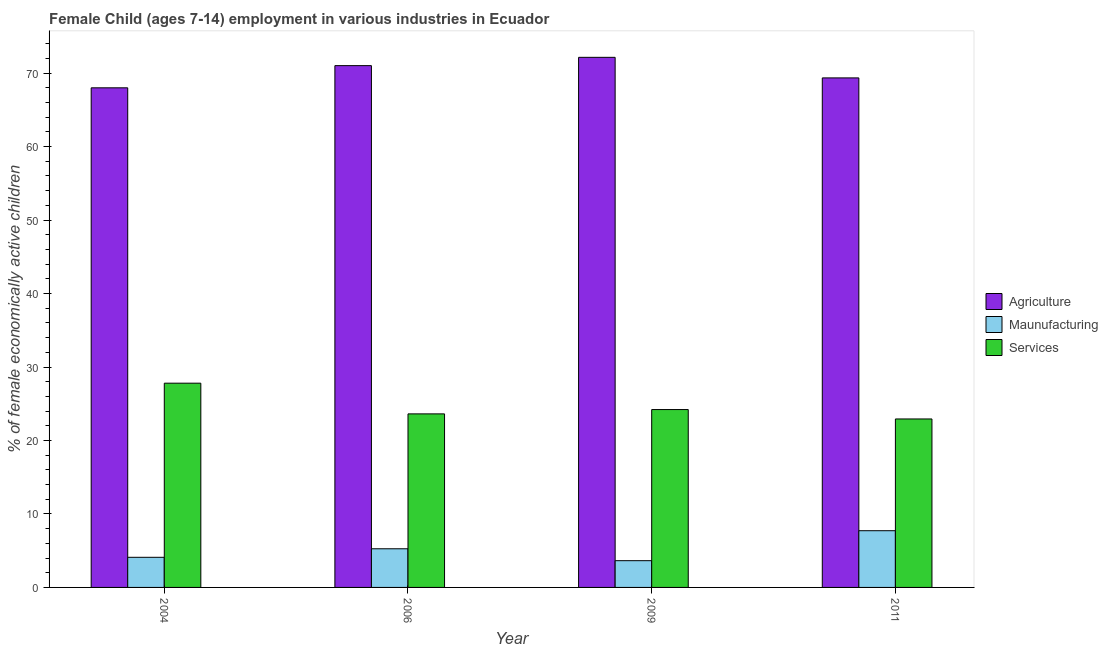How many different coloured bars are there?
Give a very brief answer. 3. How many groups of bars are there?
Provide a short and direct response. 4. Are the number of bars per tick equal to the number of legend labels?
Keep it short and to the point. Yes. How many bars are there on the 2nd tick from the left?
Offer a very short reply. 3. How many bars are there on the 2nd tick from the right?
Your answer should be very brief. 3. What is the label of the 1st group of bars from the left?
Provide a succinct answer. 2004. In how many cases, is the number of bars for a given year not equal to the number of legend labels?
Provide a short and direct response. 0. What is the percentage of economically active children in services in 2009?
Make the answer very short. 24.21. Across all years, what is the maximum percentage of economically active children in services?
Keep it short and to the point. 27.8. Across all years, what is the minimum percentage of economically active children in agriculture?
Make the answer very short. 68. In which year was the percentage of economically active children in services maximum?
Your answer should be compact. 2004. In which year was the percentage of economically active children in manufacturing minimum?
Ensure brevity in your answer.  2009. What is the total percentage of economically active children in agriculture in the graph?
Your answer should be compact. 280.52. What is the difference between the percentage of economically active children in services in 2009 and that in 2011?
Ensure brevity in your answer.  1.28. What is the difference between the percentage of economically active children in services in 2011 and the percentage of economically active children in agriculture in 2009?
Ensure brevity in your answer.  -1.28. What is the average percentage of economically active children in manufacturing per year?
Offer a terse response. 5.18. In how many years, is the percentage of economically active children in services greater than 30 %?
Give a very brief answer. 0. What is the ratio of the percentage of economically active children in agriculture in 2004 to that in 2009?
Give a very brief answer. 0.94. Is the percentage of economically active children in agriculture in 2004 less than that in 2011?
Your answer should be very brief. Yes. What is the difference between the highest and the second highest percentage of economically active children in agriculture?
Provide a short and direct response. 1.13. What is the difference between the highest and the lowest percentage of economically active children in manufacturing?
Ensure brevity in your answer.  4.08. Is the sum of the percentage of economically active children in agriculture in 2004 and 2006 greater than the maximum percentage of economically active children in manufacturing across all years?
Your answer should be very brief. Yes. What does the 2nd bar from the left in 2011 represents?
Keep it short and to the point. Maunufacturing. What does the 1st bar from the right in 2006 represents?
Offer a very short reply. Services. Is it the case that in every year, the sum of the percentage of economically active children in agriculture and percentage of economically active children in manufacturing is greater than the percentage of economically active children in services?
Keep it short and to the point. Yes. Are all the bars in the graph horizontal?
Provide a succinct answer. No. Are the values on the major ticks of Y-axis written in scientific E-notation?
Keep it short and to the point. No. Does the graph contain any zero values?
Give a very brief answer. No. Where does the legend appear in the graph?
Ensure brevity in your answer.  Center right. How many legend labels are there?
Make the answer very short. 3. What is the title of the graph?
Provide a short and direct response. Female Child (ages 7-14) employment in various industries in Ecuador. Does "ICT services" appear as one of the legend labels in the graph?
Your response must be concise. No. What is the label or title of the X-axis?
Offer a very short reply. Year. What is the label or title of the Y-axis?
Keep it short and to the point. % of female economically active children. What is the % of female economically active children in Maunufacturing in 2004?
Your answer should be compact. 4.1. What is the % of female economically active children in Services in 2004?
Give a very brief answer. 27.8. What is the % of female economically active children in Agriculture in 2006?
Provide a short and direct response. 71.02. What is the % of female economically active children of Maunufacturing in 2006?
Make the answer very short. 5.26. What is the % of female economically active children in Services in 2006?
Offer a terse response. 23.62. What is the % of female economically active children in Agriculture in 2009?
Ensure brevity in your answer.  72.15. What is the % of female economically active children in Maunufacturing in 2009?
Offer a very short reply. 3.64. What is the % of female economically active children of Services in 2009?
Keep it short and to the point. 24.21. What is the % of female economically active children in Agriculture in 2011?
Provide a succinct answer. 69.35. What is the % of female economically active children in Maunufacturing in 2011?
Give a very brief answer. 7.72. What is the % of female economically active children in Services in 2011?
Your response must be concise. 22.93. Across all years, what is the maximum % of female economically active children of Agriculture?
Ensure brevity in your answer.  72.15. Across all years, what is the maximum % of female economically active children of Maunufacturing?
Provide a succinct answer. 7.72. Across all years, what is the maximum % of female economically active children of Services?
Your answer should be very brief. 27.8. Across all years, what is the minimum % of female economically active children of Agriculture?
Offer a very short reply. 68. Across all years, what is the minimum % of female economically active children of Maunufacturing?
Ensure brevity in your answer.  3.64. Across all years, what is the minimum % of female economically active children in Services?
Give a very brief answer. 22.93. What is the total % of female economically active children in Agriculture in the graph?
Make the answer very short. 280.52. What is the total % of female economically active children of Maunufacturing in the graph?
Keep it short and to the point. 20.72. What is the total % of female economically active children of Services in the graph?
Offer a very short reply. 98.56. What is the difference between the % of female economically active children of Agriculture in 2004 and that in 2006?
Offer a terse response. -3.02. What is the difference between the % of female economically active children of Maunufacturing in 2004 and that in 2006?
Make the answer very short. -1.16. What is the difference between the % of female economically active children in Services in 2004 and that in 2006?
Provide a short and direct response. 4.18. What is the difference between the % of female economically active children in Agriculture in 2004 and that in 2009?
Offer a very short reply. -4.15. What is the difference between the % of female economically active children of Maunufacturing in 2004 and that in 2009?
Ensure brevity in your answer.  0.46. What is the difference between the % of female economically active children of Services in 2004 and that in 2009?
Ensure brevity in your answer.  3.59. What is the difference between the % of female economically active children in Agriculture in 2004 and that in 2011?
Provide a succinct answer. -1.35. What is the difference between the % of female economically active children of Maunufacturing in 2004 and that in 2011?
Your response must be concise. -3.62. What is the difference between the % of female economically active children of Services in 2004 and that in 2011?
Your answer should be very brief. 4.87. What is the difference between the % of female economically active children of Agriculture in 2006 and that in 2009?
Provide a succinct answer. -1.13. What is the difference between the % of female economically active children of Maunufacturing in 2006 and that in 2009?
Your answer should be very brief. 1.62. What is the difference between the % of female economically active children of Services in 2006 and that in 2009?
Provide a succinct answer. -0.59. What is the difference between the % of female economically active children in Agriculture in 2006 and that in 2011?
Ensure brevity in your answer.  1.67. What is the difference between the % of female economically active children of Maunufacturing in 2006 and that in 2011?
Your answer should be very brief. -2.46. What is the difference between the % of female economically active children of Services in 2006 and that in 2011?
Offer a very short reply. 0.69. What is the difference between the % of female economically active children in Agriculture in 2009 and that in 2011?
Provide a succinct answer. 2.8. What is the difference between the % of female economically active children in Maunufacturing in 2009 and that in 2011?
Ensure brevity in your answer.  -4.08. What is the difference between the % of female economically active children in Services in 2009 and that in 2011?
Offer a terse response. 1.28. What is the difference between the % of female economically active children of Agriculture in 2004 and the % of female economically active children of Maunufacturing in 2006?
Your response must be concise. 62.74. What is the difference between the % of female economically active children of Agriculture in 2004 and the % of female economically active children of Services in 2006?
Provide a succinct answer. 44.38. What is the difference between the % of female economically active children of Maunufacturing in 2004 and the % of female economically active children of Services in 2006?
Give a very brief answer. -19.52. What is the difference between the % of female economically active children in Agriculture in 2004 and the % of female economically active children in Maunufacturing in 2009?
Ensure brevity in your answer.  64.36. What is the difference between the % of female economically active children of Agriculture in 2004 and the % of female economically active children of Services in 2009?
Make the answer very short. 43.79. What is the difference between the % of female economically active children in Maunufacturing in 2004 and the % of female economically active children in Services in 2009?
Your answer should be compact. -20.11. What is the difference between the % of female economically active children of Agriculture in 2004 and the % of female economically active children of Maunufacturing in 2011?
Give a very brief answer. 60.28. What is the difference between the % of female economically active children in Agriculture in 2004 and the % of female economically active children in Services in 2011?
Your answer should be compact. 45.07. What is the difference between the % of female economically active children of Maunufacturing in 2004 and the % of female economically active children of Services in 2011?
Your answer should be compact. -18.83. What is the difference between the % of female economically active children in Agriculture in 2006 and the % of female economically active children in Maunufacturing in 2009?
Offer a very short reply. 67.38. What is the difference between the % of female economically active children of Agriculture in 2006 and the % of female economically active children of Services in 2009?
Your answer should be compact. 46.81. What is the difference between the % of female economically active children in Maunufacturing in 2006 and the % of female economically active children in Services in 2009?
Offer a terse response. -18.95. What is the difference between the % of female economically active children of Agriculture in 2006 and the % of female economically active children of Maunufacturing in 2011?
Your response must be concise. 63.3. What is the difference between the % of female economically active children of Agriculture in 2006 and the % of female economically active children of Services in 2011?
Ensure brevity in your answer.  48.09. What is the difference between the % of female economically active children in Maunufacturing in 2006 and the % of female economically active children in Services in 2011?
Offer a terse response. -17.67. What is the difference between the % of female economically active children in Agriculture in 2009 and the % of female economically active children in Maunufacturing in 2011?
Give a very brief answer. 64.43. What is the difference between the % of female economically active children of Agriculture in 2009 and the % of female economically active children of Services in 2011?
Give a very brief answer. 49.22. What is the difference between the % of female economically active children in Maunufacturing in 2009 and the % of female economically active children in Services in 2011?
Keep it short and to the point. -19.29. What is the average % of female economically active children of Agriculture per year?
Provide a succinct answer. 70.13. What is the average % of female economically active children in Maunufacturing per year?
Offer a terse response. 5.18. What is the average % of female economically active children of Services per year?
Ensure brevity in your answer.  24.64. In the year 2004, what is the difference between the % of female economically active children of Agriculture and % of female economically active children of Maunufacturing?
Your response must be concise. 63.9. In the year 2004, what is the difference between the % of female economically active children in Agriculture and % of female economically active children in Services?
Ensure brevity in your answer.  40.2. In the year 2004, what is the difference between the % of female economically active children of Maunufacturing and % of female economically active children of Services?
Ensure brevity in your answer.  -23.7. In the year 2006, what is the difference between the % of female economically active children of Agriculture and % of female economically active children of Maunufacturing?
Make the answer very short. 65.76. In the year 2006, what is the difference between the % of female economically active children in Agriculture and % of female economically active children in Services?
Offer a very short reply. 47.4. In the year 2006, what is the difference between the % of female economically active children in Maunufacturing and % of female economically active children in Services?
Your answer should be very brief. -18.36. In the year 2009, what is the difference between the % of female economically active children in Agriculture and % of female economically active children in Maunufacturing?
Keep it short and to the point. 68.51. In the year 2009, what is the difference between the % of female economically active children of Agriculture and % of female economically active children of Services?
Keep it short and to the point. 47.94. In the year 2009, what is the difference between the % of female economically active children in Maunufacturing and % of female economically active children in Services?
Provide a succinct answer. -20.57. In the year 2011, what is the difference between the % of female economically active children of Agriculture and % of female economically active children of Maunufacturing?
Your response must be concise. 61.63. In the year 2011, what is the difference between the % of female economically active children of Agriculture and % of female economically active children of Services?
Give a very brief answer. 46.42. In the year 2011, what is the difference between the % of female economically active children in Maunufacturing and % of female economically active children in Services?
Provide a succinct answer. -15.21. What is the ratio of the % of female economically active children of Agriculture in 2004 to that in 2006?
Offer a very short reply. 0.96. What is the ratio of the % of female economically active children in Maunufacturing in 2004 to that in 2006?
Keep it short and to the point. 0.78. What is the ratio of the % of female economically active children of Services in 2004 to that in 2006?
Provide a short and direct response. 1.18. What is the ratio of the % of female economically active children in Agriculture in 2004 to that in 2009?
Provide a short and direct response. 0.94. What is the ratio of the % of female economically active children of Maunufacturing in 2004 to that in 2009?
Your answer should be compact. 1.13. What is the ratio of the % of female economically active children in Services in 2004 to that in 2009?
Keep it short and to the point. 1.15. What is the ratio of the % of female economically active children of Agriculture in 2004 to that in 2011?
Keep it short and to the point. 0.98. What is the ratio of the % of female economically active children of Maunufacturing in 2004 to that in 2011?
Make the answer very short. 0.53. What is the ratio of the % of female economically active children in Services in 2004 to that in 2011?
Give a very brief answer. 1.21. What is the ratio of the % of female economically active children in Agriculture in 2006 to that in 2009?
Your response must be concise. 0.98. What is the ratio of the % of female economically active children in Maunufacturing in 2006 to that in 2009?
Keep it short and to the point. 1.45. What is the ratio of the % of female economically active children of Services in 2006 to that in 2009?
Your answer should be compact. 0.98. What is the ratio of the % of female economically active children of Agriculture in 2006 to that in 2011?
Give a very brief answer. 1.02. What is the ratio of the % of female economically active children in Maunufacturing in 2006 to that in 2011?
Offer a terse response. 0.68. What is the ratio of the % of female economically active children of Services in 2006 to that in 2011?
Keep it short and to the point. 1.03. What is the ratio of the % of female economically active children in Agriculture in 2009 to that in 2011?
Offer a very short reply. 1.04. What is the ratio of the % of female economically active children in Maunufacturing in 2009 to that in 2011?
Give a very brief answer. 0.47. What is the ratio of the % of female economically active children in Services in 2009 to that in 2011?
Ensure brevity in your answer.  1.06. What is the difference between the highest and the second highest % of female economically active children of Agriculture?
Your response must be concise. 1.13. What is the difference between the highest and the second highest % of female economically active children in Maunufacturing?
Offer a terse response. 2.46. What is the difference between the highest and the second highest % of female economically active children of Services?
Your answer should be very brief. 3.59. What is the difference between the highest and the lowest % of female economically active children of Agriculture?
Make the answer very short. 4.15. What is the difference between the highest and the lowest % of female economically active children of Maunufacturing?
Give a very brief answer. 4.08. What is the difference between the highest and the lowest % of female economically active children of Services?
Ensure brevity in your answer.  4.87. 